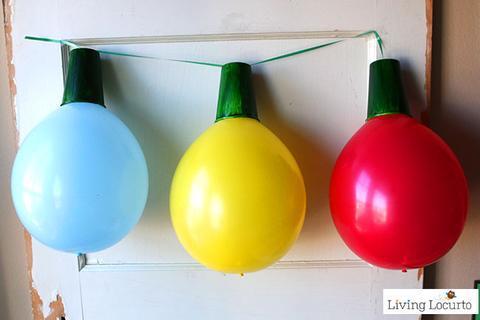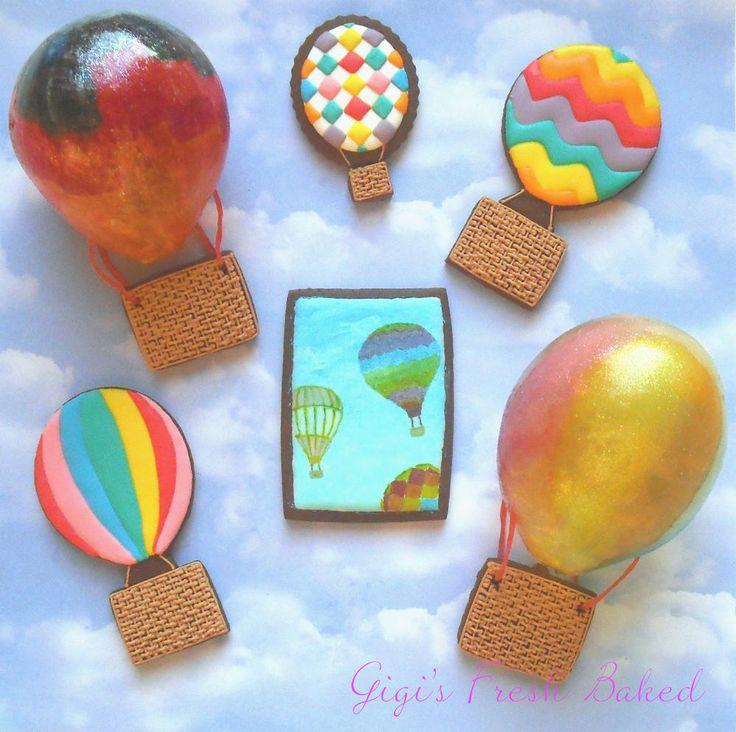The first image is the image on the left, the second image is the image on the right. Given the left and right images, does the statement "The right image features a balloon garland hung at the top of a wall and containing at least a dozen balloons." hold true? Answer yes or no. No. The first image is the image on the left, the second image is the image on the right. For the images shown, is this caption "There are exactly three colorful objects in the left image." true? Answer yes or no. Yes. 